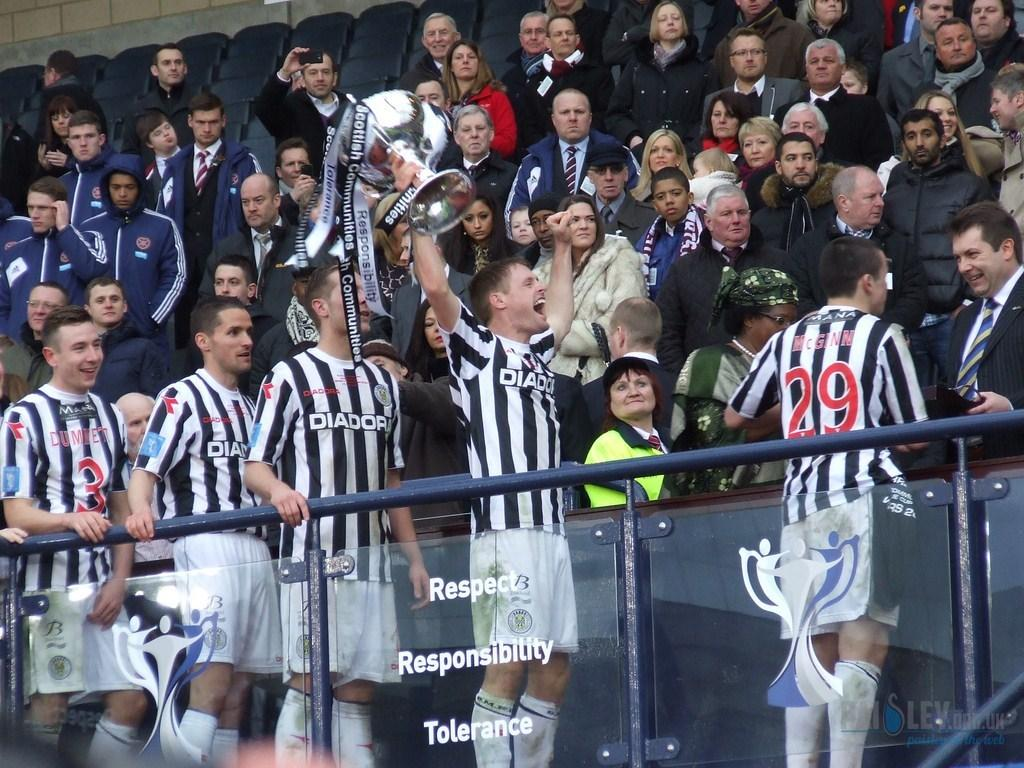Provide a one-sentence caption for the provided image. Many boys from Diador are standing in front of a large crowd. 